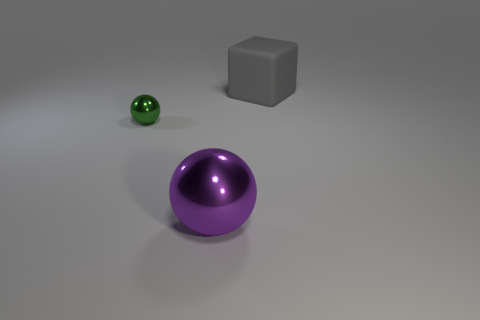What is the color of the small sphere?
Give a very brief answer. Green. What material is the object that is the same size as the gray rubber cube?
Make the answer very short. Metal. Are there any small shiny balls on the left side of the sphere in front of the small sphere?
Make the answer very short. Yes. How many other things are the same color as the small ball?
Give a very brief answer. 0. The gray matte object has what size?
Offer a terse response. Large. Are there any big metal balls?
Give a very brief answer. Yes. Are there more small green metallic balls that are on the left side of the big gray matte block than gray rubber cubes in front of the small sphere?
Offer a very short reply. Yes. There is a object that is both on the right side of the green object and behind the big metallic ball; what material is it?
Make the answer very short. Rubber. Is the tiny green thing the same shape as the big gray thing?
Give a very brief answer. No. Is there anything else that is the same size as the green object?
Make the answer very short. No. 